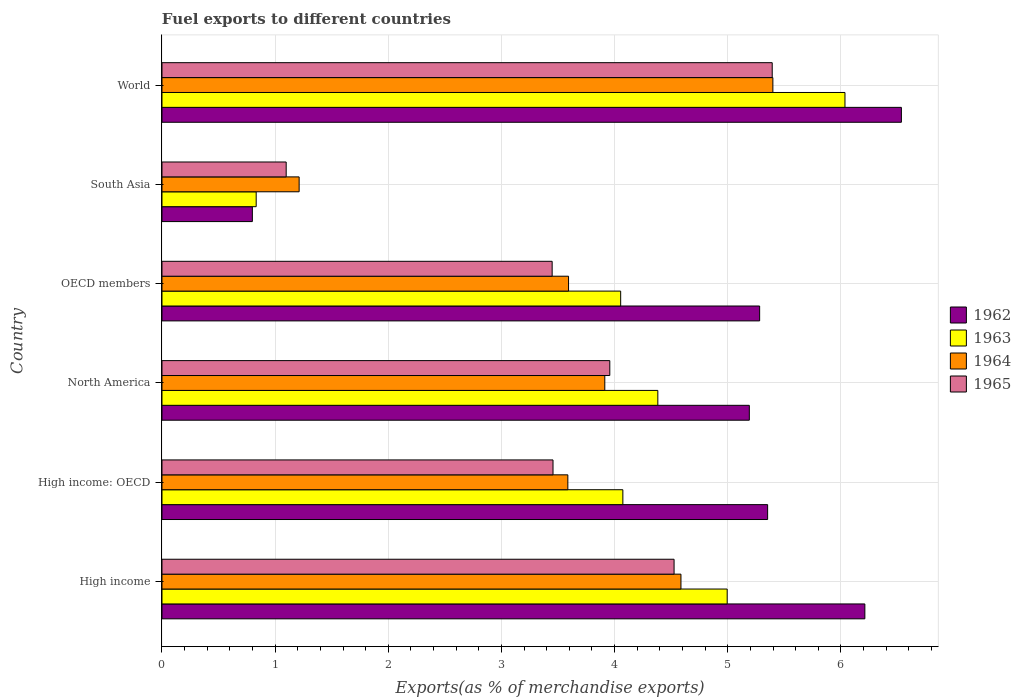How many different coloured bars are there?
Your response must be concise. 4. How many groups of bars are there?
Your answer should be compact. 6. Are the number of bars on each tick of the Y-axis equal?
Make the answer very short. Yes. How many bars are there on the 1st tick from the top?
Provide a short and direct response. 4. How many bars are there on the 1st tick from the bottom?
Provide a succinct answer. 4. In how many cases, is the number of bars for a given country not equal to the number of legend labels?
Your response must be concise. 0. What is the percentage of exports to different countries in 1964 in High income: OECD?
Provide a short and direct response. 3.59. Across all countries, what is the maximum percentage of exports to different countries in 1964?
Keep it short and to the point. 5.4. Across all countries, what is the minimum percentage of exports to different countries in 1963?
Your response must be concise. 0.83. In which country was the percentage of exports to different countries in 1962 maximum?
Provide a short and direct response. World. In which country was the percentage of exports to different countries in 1964 minimum?
Ensure brevity in your answer.  South Asia. What is the total percentage of exports to different countries in 1962 in the graph?
Your answer should be very brief. 29.37. What is the difference between the percentage of exports to different countries in 1962 in North America and that in South Asia?
Make the answer very short. 4.39. What is the difference between the percentage of exports to different countries in 1965 in OECD members and the percentage of exports to different countries in 1964 in High income?
Ensure brevity in your answer.  -1.14. What is the average percentage of exports to different countries in 1964 per country?
Your answer should be very brief. 3.72. What is the difference between the percentage of exports to different countries in 1963 and percentage of exports to different countries in 1962 in High income?
Your answer should be compact. -1.22. What is the ratio of the percentage of exports to different countries in 1964 in OECD members to that in World?
Make the answer very short. 0.67. What is the difference between the highest and the second highest percentage of exports to different countries in 1962?
Your answer should be very brief. 0.32. What is the difference between the highest and the lowest percentage of exports to different countries in 1962?
Give a very brief answer. 5.74. In how many countries, is the percentage of exports to different countries in 1965 greater than the average percentage of exports to different countries in 1965 taken over all countries?
Provide a succinct answer. 3. Is the sum of the percentage of exports to different countries in 1963 in High income and OECD members greater than the maximum percentage of exports to different countries in 1964 across all countries?
Offer a very short reply. Yes. What does the 2nd bar from the top in North America represents?
Your answer should be compact. 1964. What does the 3rd bar from the bottom in South Asia represents?
Provide a succinct answer. 1964. Is it the case that in every country, the sum of the percentage of exports to different countries in 1963 and percentage of exports to different countries in 1962 is greater than the percentage of exports to different countries in 1965?
Offer a terse response. Yes. How many bars are there?
Your response must be concise. 24. How many countries are there in the graph?
Provide a short and direct response. 6. What is the difference between two consecutive major ticks on the X-axis?
Your answer should be very brief. 1. Does the graph contain any zero values?
Offer a terse response. No. Does the graph contain grids?
Ensure brevity in your answer.  Yes. Where does the legend appear in the graph?
Provide a short and direct response. Center right. How are the legend labels stacked?
Provide a short and direct response. Vertical. What is the title of the graph?
Offer a terse response. Fuel exports to different countries. Does "2005" appear as one of the legend labels in the graph?
Ensure brevity in your answer.  No. What is the label or title of the X-axis?
Your response must be concise. Exports(as % of merchandise exports). What is the Exports(as % of merchandise exports) in 1962 in High income?
Make the answer very short. 6.21. What is the Exports(as % of merchandise exports) in 1963 in High income?
Offer a very short reply. 5. What is the Exports(as % of merchandise exports) in 1964 in High income?
Your response must be concise. 4.59. What is the Exports(as % of merchandise exports) of 1965 in High income?
Your response must be concise. 4.53. What is the Exports(as % of merchandise exports) of 1962 in High income: OECD?
Provide a short and direct response. 5.35. What is the Exports(as % of merchandise exports) of 1963 in High income: OECD?
Your answer should be compact. 4.07. What is the Exports(as % of merchandise exports) of 1964 in High income: OECD?
Your answer should be compact. 3.59. What is the Exports(as % of merchandise exports) in 1965 in High income: OECD?
Ensure brevity in your answer.  3.46. What is the Exports(as % of merchandise exports) of 1962 in North America?
Provide a short and direct response. 5.19. What is the Exports(as % of merchandise exports) in 1963 in North America?
Provide a succinct answer. 4.38. What is the Exports(as % of merchandise exports) in 1964 in North America?
Make the answer very short. 3.91. What is the Exports(as % of merchandise exports) of 1965 in North America?
Provide a short and direct response. 3.96. What is the Exports(as % of merchandise exports) of 1962 in OECD members?
Ensure brevity in your answer.  5.28. What is the Exports(as % of merchandise exports) of 1963 in OECD members?
Provide a succinct answer. 4.05. What is the Exports(as % of merchandise exports) of 1964 in OECD members?
Your answer should be very brief. 3.59. What is the Exports(as % of merchandise exports) in 1965 in OECD members?
Your answer should be compact. 3.45. What is the Exports(as % of merchandise exports) of 1962 in South Asia?
Your response must be concise. 0.8. What is the Exports(as % of merchandise exports) of 1963 in South Asia?
Offer a terse response. 0.83. What is the Exports(as % of merchandise exports) in 1964 in South Asia?
Your answer should be very brief. 1.21. What is the Exports(as % of merchandise exports) in 1965 in South Asia?
Offer a terse response. 1.1. What is the Exports(as % of merchandise exports) in 1962 in World?
Offer a terse response. 6.53. What is the Exports(as % of merchandise exports) of 1963 in World?
Ensure brevity in your answer.  6.04. What is the Exports(as % of merchandise exports) of 1964 in World?
Keep it short and to the point. 5.4. What is the Exports(as % of merchandise exports) of 1965 in World?
Provide a short and direct response. 5.39. Across all countries, what is the maximum Exports(as % of merchandise exports) in 1962?
Your response must be concise. 6.53. Across all countries, what is the maximum Exports(as % of merchandise exports) of 1963?
Make the answer very short. 6.04. Across all countries, what is the maximum Exports(as % of merchandise exports) in 1964?
Ensure brevity in your answer.  5.4. Across all countries, what is the maximum Exports(as % of merchandise exports) of 1965?
Your response must be concise. 5.39. Across all countries, what is the minimum Exports(as % of merchandise exports) of 1962?
Offer a terse response. 0.8. Across all countries, what is the minimum Exports(as % of merchandise exports) in 1963?
Your answer should be compact. 0.83. Across all countries, what is the minimum Exports(as % of merchandise exports) of 1964?
Provide a short and direct response. 1.21. Across all countries, what is the minimum Exports(as % of merchandise exports) of 1965?
Provide a succinct answer. 1.1. What is the total Exports(as % of merchandise exports) of 1962 in the graph?
Provide a succinct answer. 29.37. What is the total Exports(as % of merchandise exports) of 1963 in the graph?
Your response must be concise. 24.37. What is the total Exports(as % of merchandise exports) of 1964 in the graph?
Offer a terse response. 22.29. What is the total Exports(as % of merchandise exports) in 1965 in the graph?
Provide a succinct answer. 21.88. What is the difference between the Exports(as % of merchandise exports) of 1962 in High income and that in High income: OECD?
Ensure brevity in your answer.  0.86. What is the difference between the Exports(as % of merchandise exports) in 1963 in High income and that in High income: OECD?
Provide a short and direct response. 0.92. What is the difference between the Exports(as % of merchandise exports) in 1964 in High income and that in High income: OECD?
Your response must be concise. 1. What is the difference between the Exports(as % of merchandise exports) in 1965 in High income and that in High income: OECD?
Provide a succinct answer. 1.07. What is the difference between the Exports(as % of merchandise exports) of 1963 in High income and that in North America?
Your answer should be very brief. 0.61. What is the difference between the Exports(as % of merchandise exports) of 1964 in High income and that in North America?
Provide a short and direct response. 0.67. What is the difference between the Exports(as % of merchandise exports) of 1965 in High income and that in North America?
Keep it short and to the point. 0.57. What is the difference between the Exports(as % of merchandise exports) in 1962 in High income and that in OECD members?
Your answer should be very brief. 0.93. What is the difference between the Exports(as % of merchandise exports) of 1963 in High income and that in OECD members?
Make the answer very short. 0.94. What is the difference between the Exports(as % of merchandise exports) of 1964 in High income and that in OECD members?
Your response must be concise. 0.99. What is the difference between the Exports(as % of merchandise exports) in 1965 in High income and that in OECD members?
Offer a very short reply. 1.08. What is the difference between the Exports(as % of merchandise exports) of 1962 in High income and that in South Asia?
Offer a terse response. 5.41. What is the difference between the Exports(as % of merchandise exports) in 1963 in High income and that in South Asia?
Your response must be concise. 4.16. What is the difference between the Exports(as % of merchandise exports) in 1964 in High income and that in South Asia?
Keep it short and to the point. 3.37. What is the difference between the Exports(as % of merchandise exports) of 1965 in High income and that in South Asia?
Keep it short and to the point. 3.43. What is the difference between the Exports(as % of merchandise exports) of 1962 in High income and that in World?
Your response must be concise. -0.32. What is the difference between the Exports(as % of merchandise exports) of 1963 in High income and that in World?
Make the answer very short. -1.04. What is the difference between the Exports(as % of merchandise exports) of 1964 in High income and that in World?
Offer a very short reply. -0.81. What is the difference between the Exports(as % of merchandise exports) of 1965 in High income and that in World?
Ensure brevity in your answer.  -0.87. What is the difference between the Exports(as % of merchandise exports) of 1962 in High income: OECD and that in North America?
Give a very brief answer. 0.16. What is the difference between the Exports(as % of merchandise exports) of 1963 in High income: OECD and that in North America?
Offer a terse response. -0.31. What is the difference between the Exports(as % of merchandise exports) of 1964 in High income: OECD and that in North America?
Your answer should be very brief. -0.33. What is the difference between the Exports(as % of merchandise exports) of 1965 in High income: OECD and that in North America?
Your response must be concise. -0.5. What is the difference between the Exports(as % of merchandise exports) of 1962 in High income: OECD and that in OECD members?
Offer a terse response. 0.07. What is the difference between the Exports(as % of merchandise exports) in 1963 in High income: OECD and that in OECD members?
Ensure brevity in your answer.  0.02. What is the difference between the Exports(as % of merchandise exports) in 1964 in High income: OECD and that in OECD members?
Provide a succinct answer. -0.01. What is the difference between the Exports(as % of merchandise exports) of 1965 in High income: OECD and that in OECD members?
Offer a very short reply. 0.01. What is the difference between the Exports(as % of merchandise exports) in 1962 in High income: OECD and that in South Asia?
Make the answer very short. 4.55. What is the difference between the Exports(as % of merchandise exports) in 1963 in High income: OECD and that in South Asia?
Ensure brevity in your answer.  3.24. What is the difference between the Exports(as % of merchandise exports) of 1964 in High income: OECD and that in South Asia?
Your answer should be compact. 2.37. What is the difference between the Exports(as % of merchandise exports) in 1965 in High income: OECD and that in South Asia?
Offer a terse response. 2.36. What is the difference between the Exports(as % of merchandise exports) in 1962 in High income: OECD and that in World?
Your answer should be compact. -1.18. What is the difference between the Exports(as % of merchandise exports) of 1963 in High income: OECD and that in World?
Make the answer very short. -1.96. What is the difference between the Exports(as % of merchandise exports) in 1964 in High income: OECD and that in World?
Provide a succinct answer. -1.81. What is the difference between the Exports(as % of merchandise exports) in 1965 in High income: OECD and that in World?
Provide a short and direct response. -1.94. What is the difference between the Exports(as % of merchandise exports) of 1962 in North America and that in OECD members?
Your response must be concise. -0.09. What is the difference between the Exports(as % of merchandise exports) of 1963 in North America and that in OECD members?
Offer a terse response. 0.33. What is the difference between the Exports(as % of merchandise exports) in 1964 in North America and that in OECD members?
Give a very brief answer. 0.32. What is the difference between the Exports(as % of merchandise exports) in 1965 in North America and that in OECD members?
Your answer should be compact. 0.51. What is the difference between the Exports(as % of merchandise exports) in 1962 in North America and that in South Asia?
Your answer should be compact. 4.39. What is the difference between the Exports(as % of merchandise exports) of 1963 in North America and that in South Asia?
Offer a very short reply. 3.55. What is the difference between the Exports(as % of merchandise exports) of 1964 in North America and that in South Asia?
Your answer should be compact. 2.7. What is the difference between the Exports(as % of merchandise exports) of 1965 in North America and that in South Asia?
Give a very brief answer. 2.86. What is the difference between the Exports(as % of merchandise exports) in 1962 in North America and that in World?
Make the answer very short. -1.34. What is the difference between the Exports(as % of merchandise exports) of 1963 in North America and that in World?
Your answer should be compact. -1.65. What is the difference between the Exports(as % of merchandise exports) in 1964 in North America and that in World?
Provide a short and direct response. -1.49. What is the difference between the Exports(as % of merchandise exports) in 1965 in North America and that in World?
Provide a short and direct response. -1.44. What is the difference between the Exports(as % of merchandise exports) in 1962 in OECD members and that in South Asia?
Offer a terse response. 4.48. What is the difference between the Exports(as % of merchandise exports) of 1963 in OECD members and that in South Asia?
Provide a succinct answer. 3.22. What is the difference between the Exports(as % of merchandise exports) in 1964 in OECD members and that in South Asia?
Your response must be concise. 2.38. What is the difference between the Exports(as % of merchandise exports) of 1965 in OECD members and that in South Asia?
Provide a succinct answer. 2.35. What is the difference between the Exports(as % of merchandise exports) in 1962 in OECD members and that in World?
Your response must be concise. -1.25. What is the difference between the Exports(as % of merchandise exports) in 1963 in OECD members and that in World?
Provide a succinct answer. -1.98. What is the difference between the Exports(as % of merchandise exports) of 1964 in OECD members and that in World?
Your answer should be very brief. -1.81. What is the difference between the Exports(as % of merchandise exports) in 1965 in OECD members and that in World?
Offer a terse response. -1.94. What is the difference between the Exports(as % of merchandise exports) of 1962 in South Asia and that in World?
Provide a short and direct response. -5.74. What is the difference between the Exports(as % of merchandise exports) in 1963 in South Asia and that in World?
Offer a very short reply. -5.2. What is the difference between the Exports(as % of merchandise exports) of 1964 in South Asia and that in World?
Your answer should be compact. -4.19. What is the difference between the Exports(as % of merchandise exports) of 1965 in South Asia and that in World?
Ensure brevity in your answer.  -4.3. What is the difference between the Exports(as % of merchandise exports) in 1962 in High income and the Exports(as % of merchandise exports) in 1963 in High income: OECD?
Your answer should be very brief. 2.14. What is the difference between the Exports(as % of merchandise exports) of 1962 in High income and the Exports(as % of merchandise exports) of 1964 in High income: OECD?
Your response must be concise. 2.62. What is the difference between the Exports(as % of merchandise exports) of 1962 in High income and the Exports(as % of merchandise exports) of 1965 in High income: OECD?
Ensure brevity in your answer.  2.76. What is the difference between the Exports(as % of merchandise exports) of 1963 in High income and the Exports(as % of merchandise exports) of 1964 in High income: OECD?
Offer a terse response. 1.41. What is the difference between the Exports(as % of merchandise exports) of 1963 in High income and the Exports(as % of merchandise exports) of 1965 in High income: OECD?
Ensure brevity in your answer.  1.54. What is the difference between the Exports(as % of merchandise exports) of 1964 in High income and the Exports(as % of merchandise exports) of 1965 in High income: OECD?
Ensure brevity in your answer.  1.13. What is the difference between the Exports(as % of merchandise exports) in 1962 in High income and the Exports(as % of merchandise exports) in 1963 in North America?
Ensure brevity in your answer.  1.83. What is the difference between the Exports(as % of merchandise exports) of 1962 in High income and the Exports(as % of merchandise exports) of 1964 in North America?
Your answer should be very brief. 2.3. What is the difference between the Exports(as % of merchandise exports) in 1962 in High income and the Exports(as % of merchandise exports) in 1965 in North America?
Offer a very short reply. 2.25. What is the difference between the Exports(as % of merchandise exports) of 1963 in High income and the Exports(as % of merchandise exports) of 1964 in North America?
Your answer should be compact. 1.08. What is the difference between the Exports(as % of merchandise exports) of 1963 in High income and the Exports(as % of merchandise exports) of 1965 in North America?
Ensure brevity in your answer.  1.04. What is the difference between the Exports(as % of merchandise exports) of 1964 in High income and the Exports(as % of merchandise exports) of 1965 in North America?
Provide a short and direct response. 0.63. What is the difference between the Exports(as % of merchandise exports) of 1962 in High income and the Exports(as % of merchandise exports) of 1963 in OECD members?
Make the answer very short. 2.16. What is the difference between the Exports(as % of merchandise exports) in 1962 in High income and the Exports(as % of merchandise exports) in 1964 in OECD members?
Ensure brevity in your answer.  2.62. What is the difference between the Exports(as % of merchandise exports) of 1962 in High income and the Exports(as % of merchandise exports) of 1965 in OECD members?
Give a very brief answer. 2.76. What is the difference between the Exports(as % of merchandise exports) of 1963 in High income and the Exports(as % of merchandise exports) of 1964 in OECD members?
Ensure brevity in your answer.  1.4. What is the difference between the Exports(as % of merchandise exports) of 1963 in High income and the Exports(as % of merchandise exports) of 1965 in OECD members?
Offer a terse response. 1.55. What is the difference between the Exports(as % of merchandise exports) of 1964 in High income and the Exports(as % of merchandise exports) of 1965 in OECD members?
Your answer should be very brief. 1.14. What is the difference between the Exports(as % of merchandise exports) in 1962 in High income and the Exports(as % of merchandise exports) in 1963 in South Asia?
Offer a very short reply. 5.38. What is the difference between the Exports(as % of merchandise exports) in 1962 in High income and the Exports(as % of merchandise exports) in 1964 in South Asia?
Your answer should be very brief. 5. What is the difference between the Exports(as % of merchandise exports) in 1962 in High income and the Exports(as % of merchandise exports) in 1965 in South Asia?
Offer a very short reply. 5.11. What is the difference between the Exports(as % of merchandise exports) in 1963 in High income and the Exports(as % of merchandise exports) in 1964 in South Asia?
Give a very brief answer. 3.78. What is the difference between the Exports(as % of merchandise exports) in 1963 in High income and the Exports(as % of merchandise exports) in 1965 in South Asia?
Offer a very short reply. 3.9. What is the difference between the Exports(as % of merchandise exports) of 1964 in High income and the Exports(as % of merchandise exports) of 1965 in South Asia?
Ensure brevity in your answer.  3.49. What is the difference between the Exports(as % of merchandise exports) of 1962 in High income and the Exports(as % of merchandise exports) of 1963 in World?
Your answer should be very brief. 0.18. What is the difference between the Exports(as % of merchandise exports) in 1962 in High income and the Exports(as % of merchandise exports) in 1964 in World?
Your answer should be compact. 0.81. What is the difference between the Exports(as % of merchandise exports) in 1962 in High income and the Exports(as % of merchandise exports) in 1965 in World?
Provide a short and direct response. 0.82. What is the difference between the Exports(as % of merchandise exports) in 1963 in High income and the Exports(as % of merchandise exports) in 1964 in World?
Your answer should be very brief. -0.4. What is the difference between the Exports(as % of merchandise exports) in 1963 in High income and the Exports(as % of merchandise exports) in 1965 in World?
Ensure brevity in your answer.  -0.4. What is the difference between the Exports(as % of merchandise exports) of 1964 in High income and the Exports(as % of merchandise exports) of 1965 in World?
Ensure brevity in your answer.  -0.81. What is the difference between the Exports(as % of merchandise exports) of 1962 in High income: OECD and the Exports(as % of merchandise exports) of 1963 in North America?
Make the answer very short. 0.97. What is the difference between the Exports(as % of merchandise exports) in 1962 in High income: OECD and the Exports(as % of merchandise exports) in 1964 in North America?
Offer a very short reply. 1.44. What is the difference between the Exports(as % of merchandise exports) of 1962 in High income: OECD and the Exports(as % of merchandise exports) of 1965 in North America?
Offer a very short reply. 1.39. What is the difference between the Exports(as % of merchandise exports) of 1963 in High income: OECD and the Exports(as % of merchandise exports) of 1964 in North America?
Ensure brevity in your answer.  0.16. What is the difference between the Exports(as % of merchandise exports) of 1963 in High income: OECD and the Exports(as % of merchandise exports) of 1965 in North America?
Your response must be concise. 0.12. What is the difference between the Exports(as % of merchandise exports) of 1964 in High income: OECD and the Exports(as % of merchandise exports) of 1965 in North America?
Provide a succinct answer. -0.37. What is the difference between the Exports(as % of merchandise exports) of 1962 in High income: OECD and the Exports(as % of merchandise exports) of 1963 in OECD members?
Give a very brief answer. 1.3. What is the difference between the Exports(as % of merchandise exports) of 1962 in High income: OECD and the Exports(as % of merchandise exports) of 1964 in OECD members?
Offer a terse response. 1.76. What is the difference between the Exports(as % of merchandise exports) of 1962 in High income: OECD and the Exports(as % of merchandise exports) of 1965 in OECD members?
Offer a terse response. 1.9. What is the difference between the Exports(as % of merchandise exports) of 1963 in High income: OECD and the Exports(as % of merchandise exports) of 1964 in OECD members?
Make the answer very short. 0.48. What is the difference between the Exports(as % of merchandise exports) in 1963 in High income: OECD and the Exports(as % of merchandise exports) in 1965 in OECD members?
Give a very brief answer. 0.62. What is the difference between the Exports(as % of merchandise exports) of 1964 in High income: OECD and the Exports(as % of merchandise exports) of 1965 in OECD members?
Your answer should be compact. 0.14. What is the difference between the Exports(as % of merchandise exports) of 1962 in High income: OECD and the Exports(as % of merchandise exports) of 1963 in South Asia?
Your response must be concise. 4.52. What is the difference between the Exports(as % of merchandise exports) in 1962 in High income: OECD and the Exports(as % of merchandise exports) in 1964 in South Asia?
Keep it short and to the point. 4.14. What is the difference between the Exports(as % of merchandise exports) in 1962 in High income: OECD and the Exports(as % of merchandise exports) in 1965 in South Asia?
Keep it short and to the point. 4.25. What is the difference between the Exports(as % of merchandise exports) in 1963 in High income: OECD and the Exports(as % of merchandise exports) in 1964 in South Asia?
Offer a terse response. 2.86. What is the difference between the Exports(as % of merchandise exports) in 1963 in High income: OECD and the Exports(as % of merchandise exports) in 1965 in South Asia?
Provide a succinct answer. 2.98. What is the difference between the Exports(as % of merchandise exports) of 1964 in High income: OECD and the Exports(as % of merchandise exports) of 1965 in South Asia?
Ensure brevity in your answer.  2.49. What is the difference between the Exports(as % of merchandise exports) of 1962 in High income: OECD and the Exports(as % of merchandise exports) of 1963 in World?
Keep it short and to the point. -0.68. What is the difference between the Exports(as % of merchandise exports) in 1962 in High income: OECD and the Exports(as % of merchandise exports) in 1964 in World?
Provide a succinct answer. -0.05. What is the difference between the Exports(as % of merchandise exports) in 1962 in High income: OECD and the Exports(as % of merchandise exports) in 1965 in World?
Give a very brief answer. -0.04. What is the difference between the Exports(as % of merchandise exports) in 1963 in High income: OECD and the Exports(as % of merchandise exports) in 1964 in World?
Provide a succinct answer. -1.33. What is the difference between the Exports(as % of merchandise exports) of 1963 in High income: OECD and the Exports(as % of merchandise exports) of 1965 in World?
Your answer should be compact. -1.32. What is the difference between the Exports(as % of merchandise exports) in 1964 in High income: OECD and the Exports(as % of merchandise exports) in 1965 in World?
Ensure brevity in your answer.  -1.81. What is the difference between the Exports(as % of merchandise exports) of 1962 in North America and the Exports(as % of merchandise exports) of 1963 in OECD members?
Provide a succinct answer. 1.14. What is the difference between the Exports(as % of merchandise exports) of 1962 in North America and the Exports(as % of merchandise exports) of 1964 in OECD members?
Your answer should be compact. 1.6. What is the difference between the Exports(as % of merchandise exports) of 1962 in North America and the Exports(as % of merchandise exports) of 1965 in OECD members?
Keep it short and to the point. 1.74. What is the difference between the Exports(as % of merchandise exports) in 1963 in North America and the Exports(as % of merchandise exports) in 1964 in OECD members?
Make the answer very short. 0.79. What is the difference between the Exports(as % of merchandise exports) of 1963 in North America and the Exports(as % of merchandise exports) of 1965 in OECD members?
Make the answer very short. 0.93. What is the difference between the Exports(as % of merchandise exports) of 1964 in North America and the Exports(as % of merchandise exports) of 1965 in OECD members?
Ensure brevity in your answer.  0.47. What is the difference between the Exports(as % of merchandise exports) in 1962 in North America and the Exports(as % of merchandise exports) in 1963 in South Asia?
Your answer should be very brief. 4.36. What is the difference between the Exports(as % of merchandise exports) in 1962 in North America and the Exports(as % of merchandise exports) in 1964 in South Asia?
Give a very brief answer. 3.98. What is the difference between the Exports(as % of merchandise exports) of 1962 in North America and the Exports(as % of merchandise exports) of 1965 in South Asia?
Your answer should be compact. 4.09. What is the difference between the Exports(as % of merchandise exports) in 1963 in North America and the Exports(as % of merchandise exports) in 1964 in South Asia?
Offer a very short reply. 3.17. What is the difference between the Exports(as % of merchandise exports) of 1963 in North America and the Exports(as % of merchandise exports) of 1965 in South Asia?
Provide a short and direct response. 3.28. What is the difference between the Exports(as % of merchandise exports) of 1964 in North America and the Exports(as % of merchandise exports) of 1965 in South Asia?
Offer a very short reply. 2.82. What is the difference between the Exports(as % of merchandise exports) in 1962 in North America and the Exports(as % of merchandise exports) in 1963 in World?
Give a very brief answer. -0.85. What is the difference between the Exports(as % of merchandise exports) of 1962 in North America and the Exports(as % of merchandise exports) of 1964 in World?
Give a very brief answer. -0.21. What is the difference between the Exports(as % of merchandise exports) of 1962 in North America and the Exports(as % of merchandise exports) of 1965 in World?
Your answer should be very brief. -0.2. What is the difference between the Exports(as % of merchandise exports) in 1963 in North America and the Exports(as % of merchandise exports) in 1964 in World?
Your answer should be compact. -1.02. What is the difference between the Exports(as % of merchandise exports) in 1963 in North America and the Exports(as % of merchandise exports) in 1965 in World?
Provide a short and direct response. -1.01. What is the difference between the Exports(as % of merchandise exports) in 1964 in North America and the Exports(as % of merchandise exports) in 1965 in World?
Offer a terse response. -1.48. What is the difference between the Exports(as % of merchandise exports) of 1962 in OECD members and the Exports(as % of merchandise exports) of 1963 in South Asia?
Make the answer very short. 4.45. What is the difference between the Exports(as % of merchandise exports) in 1962 in OECD members and the Exports(as % of merchandise exports) in 1964 in South Asia?
Ensure brevity in your answer.  4.07. What is the difference between the Exports(as % of merchandise exports) of 1962 in OECD members and the Exports(as % of merchandise exports) of 1965 in South Asia?
Give a very brief answer. 4.18. What is the difference between the Exports(as % of merchandise exports) of 1963 in OECD members and the Exports(as % of merchandise exports) of 1964 in South Asia?
Offer a terse response. 2.84. What is the difference between the Exports(as % of merchandise exports) of 1963 in OECD members and the Exports(as % of merchandise exports) of 1965 in South Asia?
Provide a succinct answer. 2.96. What is the difference between the Exports(as % of merchandise exports) in 1964 in OECD members and the Exports(as % of merchandise exports) in 1965 in South Asia?
Offer a terse response. 2.5. What is the difference between the Exports(as % of merchandise exports) of 1962 in OECD members and the Exports(as % of merchandise exports) of 1963 in World?
Offer a very short reply. -0.75. What is the difference between the Exports(as % of merchandise exports) in 1962 in OECD members and the Exports(as % of merchandise exports) in 1964 in World?
Offer a very short reply. -0.12. What is the difference between the Exports(as % of merchandise exports) of 1962 in OECD members and the Exports(as % of merchandise exports) of 1965 in World?
Keep it short and to the point. -0.11. What is the difference between the Exports(as % of merchandise exports) of 1963 in OECD members and the Exports(as % of merchandise exports) of 1964 in World?
Offer a terse response. -1.35. What is the difference between the Exports(as % of merchandise exports) of 1963 in OECD members and the Exports(as % of merchandise exports) of 1965 in World?
Ensure brevity in your answer.  -1.34. What is the difference between the Exports(as % of merchandise exports) of 1964 in OECD members and the Exports(as % of merchandise exports) of 1965 in World?
Ensure brevity in your answer.  -1.8. What is the difference between the Exports(as % of merchandise exports) of 1962 in South Asia and the Exports(as % of merchandise exports) of 1963 in World?
Your answer should be compact. -5.24. What is the difference between the Exports(as % of merchandise exports) in 1962 in South Asia and the Exports(as % of merchandise exports) in 1964 in World?
Your answer should be compact. -4.6. What is the difference between the Exports(as % of merchandise exports) of 1962 in South Asia and the Exports(as % of merchandise exports) of 1965 in World?
Keep it short and to the point. -4.59. What is the difference between the Exports(as % of merchandise exports) in 1963 in South Asia and the Exports(as % of merchandise exports) in 1964 in World?
Give a very brief answer. -4.57. What is the difference between the Exports(as % of merchandise exports) in 1963 in South Asia and the Exports(as % of merchandise exports) in 1965 in World?
Your answer should be compact. -4.56. What is the difference between the Exports(as % of merchandise exports) of 1964 in South Asia and the Exports(as % of merchandise exports) of 1965 in World?
Your answer should be compact. -4.18. What is the average Exports(as % of merchandise exports) of 1962 per country?
Provide a short and direct response. 4.9. What is the average Exports(as % of merchandise exports) of 1963 per country?
Provide a succinct answer. 4.06. What is the average Exports(as % of merchandise exports) in 1964 per country?
Keep it short and to the point. 3.72. What is the average Exports(as % of merchandise exports) in 1965 per country?
Give a very brief answer. 3.65. What is the difference between the Exports(as % of merchandise exports) in 1962 and Exports(as % of merchandise exports) in 1963 in High income?
Your answer should be compact. 1.22. What is the difference between the Exports(as % of merchandise exports) in 1962 and Exports(as % of merchandise exports) in 1964 in High income?
Your answer should be compact. 1.63. What is the difference between the Exports(as % of merchandise exports) in 1962 and Exports(as % of merchandise exports) in 1965 in High income?
Keep it short and to the point. 1.69. What is the difference between the Exports(as % of merchandise exports) of 1963 and Exports(as % of merchandise exports) of 1964 in High income?
Your answer should be compact. 0.41. What is the difference between the Exports(as % of merchandise exports) of 1963 and Exports(as % of merchandise exports) of 1965 in High income?
Offer a very short reply. 0.47. What is the difference between the Exports(as % of merchandise exports) of 1964 and Exports(as % of merchandise exports) of 1965 in High income?
Ensure brevity in your answer.  0.06. What is the difference between the Exports(as % of merchandise exports) of 1962 and Exports(as % of merchandise exports) of 1963 in High income: OECD?
Your response must be concise. 1.28. What is the difference between the Exports(as % of merchandise exports) of 1962 and Exports(as % of merchandise exports) of 1964 in High income: OECD?
Offer a very short reply. 1.77. What is the difference between the Exports(as % of merchandise exports) in 1962 and Exports(as % of merchandise exports) in 1965 in High income: OECD?
Keep it short and to the point. 1.9. What is the difference between the Exports(as % of merchandise exports) in 1963 and Exports(as % of merchandise exports) in 1964 in High income: OECD?
Offer a terse response. 0.49. What is the difference between the Exports(as % of merchandise exports) in 1963 and Exports(as % of merchandise exports) in 1965 in High income: OECD?
Keep it short and to the point. 0.62. What is the difference between the Exports(as % of merchandise exports) in 1964 and Exports(as % of merchandise exports) in 1965 in High income: OECD?
Make the answer very short. 0.13. What is the difference between the Exports(as % of merchandise exports) of 1962 and Exports(as % of merchandise exports) of 1963 in North America?
Ensure brevity in your answer.  0.81. What is the difference between the Exports(as % of merchandise exports) in 1962 and Exports(as % of merchandise exports) in 1964 in North America?
Provide a short and direct response. 1.28. What is the difference between the Exports(as % of merchandise exports) of 1962 and Exports(as % of merchandise exports) of 1965 in North America?
Offer a very short reply. 1.23. What is the difference between the Exports(as % of merchandise exports) of 1963 and Exports(as % of merchandise exports) of 1964 in North America?
Your answer should be very brief. 0.47. What is the difference between the Exports(as % of merchandise exports) in 1963 and Exports(as % of merchandise exports) in 1965 in North America?
Your response must be concise. 0.42. What is the difference between the Exports(as % of merchandise exports) of 1964 and Exports(as % of merchandise exports) of 1965 in North America?
Keep it short and to the point. -0.04. What is the difference between the Exports(as % of merchandise exports) in 1962 and Exports(as % of merchandise exports) in 1963 in OECD members?
Ensure brevity in your answer.  1.23. What is the difference between the Exports(as % of merchandise exports) in 1962 and Exports(as % of merchandise exports) in 1964 in OECD members?
Your answer should be very brief. 1.69. What is the difference between the Exports(as % of merchandise exports) of 1962 and Exports(as % of merchandise exports) of 1965 in OECD members?
Ensure brevity in your answer.  1.83. What is the difference between the Exports(as % of merchandise exports) of 1963 and Exports(as % of merchandise exports) of 1964 in OECD members?
Make the answer very short. 0.46. What is the difference between the Exports(as % of merchandise exports) of 1963 and Exports(as % of merchandise exports) of 1965 in OECD members?
Your response must be concise. 0.61. What is the difference between the Exports(as % of merchandise exports) of 1964 and Exports(as % of merchandise exports) of 1965 in OECD members?
Offer a very short reply. 0.14. What is the difference between the Exports(as % of merchandise exports) of 1962 and Exports(as % of merchandise exports) of 1963 in South Asia?
Give a very brief answer. -0.03. What is the difference between the Exports(as % of merchandise exports) of 1962 and Exports(as % of merchandise exports) of 1964 in South Asia?
Keep it short and to the point. -0.41. What is the difference between the Exports(as % of merchandise exports) in 1962 and Exports(as % of merchandise exports) in 1965 in South Asia?
Your response must be concise. -0.3. What is the difference between the Exports(as % of merchandise exports) in 1963 and Exports(as % of merchandise exports) in 1964 in South Asia?
Keep it short and to the point. -0.38. What is the difference between the Exports(as % of merchandise exports) of 1963 and Exports(as % of merchandise exports) of 1965 in South Asia?
Your answer should be very brief. -0.27. What is the difference between the Exports(as % of merchandise exports) in 1964 and Exports(as % of merchandise exports) in 1965 in South Asia?
Your answer should be compact. 0.11. What is the difference between the Exports(as % of merchandise exports) in 1962 and Exports(as % of merchandise exports) in 1963 in World?
Offer a very short reply. 0.5. What is the difference between the Exports(as % of merchandise exports) in 1962 and Exports(as % of merchandise exports) in 1964 in World?
Your answer should be compact. 1.14. What is the difference between the Exports(as % of merchandise exports) in 1962 and Exports(as % of merchandise exports) in 1965 in World?
Make the answer very short. 1.14. What is the difference between the Exports(as % of merchandise exports) of 1963 and Exports(as % of merchandise exports) of 1964 in World?
Your answer should be very brief. 0.64. What is the difference between the Exports(as % of merchandise exports) of 1963 and Exports(as % of merchandise exports) of 1965 in World?
Give a very brief answer. 0.64. What is the difference between the Exports(as % of merchandise exports) of 1964 and Exports(as % of merchandise exports) of 1965 in World?
Ensure brevity in your answer.  0.01. What is the ratio of the Exports(as % of merchandise exports) of 1962 in High income to that in High income: OECD?
Offer a terse response. 1.16. What is the ratio of the Exports(as % of merchandise exports) in 1963 in High income to that in High income: OECD?
Provide a succinct answer. 1.23. What is the ratio of the Exports(as % of merchandise exports) in 1964 in High income to that in High income: OECD?
Your answer should be compact. 1.28. What is the ratio of the Exports(as % of merchandise exports) of 1965 in High income to that in High income: OECD?
Your answer should be compact. 1.31. What is the ratio of the Exports(as % of merchandise exports) in 1962 in High income to that in North America?
Your answer should be compact. 1.2. What is the ratio of the Exports(as % of merchandise exports) of 1963 in High income to that in North America?
Keep it short and to the point. 1.14. What is the ratio of the Exports(as % of merchandise exports) of 1964 in High income to that in North America?
Your answer should be very brief. 1.17. What is the ratio of the Exports(as % of merchandise exports) of 1965 in High income to that in North America?
Make the answer very short. 1.14. What is the ratio of the Exports(as % of merchandise exports) of 1962 in High income to that in OECD members?
Your answer should be very brief. 1.18. What is the ratio of the Exports(as % of merchandise exports) in 1963 in High income to that in OECD members?
Keep it short and to the point. 1.23. What is the ratio of the Exports(as % of merchandise exports) in 1964 in High income to that in OECD members?
Provide a succinct answer. 1.28. What is the ratio of the Exports(as % of merchandise exports) in 1965 in High income to that in OECD members?
Provide a succinct answer. 1.31. What is the ratio of the Exports(as % of merchandise exports) of 1962 in High income to that in South Asia?
Give a very brief answer. 7.78. What is the ratio of the Exports(as % of merchandise exports) in 1963 in High income to that in South Asia?
Offer a very short reply. 6. What is the ratio of the Exports(as % of merchandise exports) in 1964 in High income to that in South Asia?
Your answer should be compact. 3.78. What is the ratio of the Exports(as % of merchandise exports) of 1965 in High income to that in South Asia?
Provide a short and direct response. 4.12. What is the ratio of the Exports(as % of merchandise exports) in 1962 in High income to that in World?
Keep it short and to the point. 0.95. What is the ratio of the Exports(as % of merchandise exports) in 1963 in High income to that in World?
Give a very brief answer. 0.83. What is the ratio of the Exports(as % of merchandise exports) of 1964 in High income to that in World?
Your response must be concise. 0.85. What is the ratio of the Exports(as % of merchandise exports) in 1965 in High income to that in World?
Make the answer very short. 0.84. What is the ratio of the Exports(as % of merchandise exports) of 1962 in High income: OECD to that in North America?
Keep it short and to the point. 1.03. What is the ratio of the Exports(as % of merchandise exports) of 1963 in High income: OECD to that in North America?
Your answer should be very brief. 0.93. What is the ratio of the Exports(as % of merchandise exports) of 1964 in High income: OECD to that in North America?
Offer a very short reply. 0.92. What is the ratio of the Exports(as % of merchandise exports) of 1965 in High income: OECD to that in North America?
Provide a short and direct response. 0.87. What is the ratio of the Exports(as % of merchandise exports) in 1962 in High income: OECD to that in OECD members?
Offer a terse response. 1.01. What is the ratio of the Exports(as % of merchandise exports) in 1962 in High income: OECD to that in South Asia?
Provide a succinct answer. 6.7. What is the ratio of the Exports(as % of merchandise exports) in 1963 in High income: OECD to that in South Asia?
Offer a very short reply. 4.89. What is the ratio of the Exports(as % of merchandise exports) of 1964 in High income: OECD to that in South Asia?
Provide a succinct answer. 2.96. What is the ratio of the Exports(as % of merchandise exports) in 1965 in High income: OECD to that in South Asia?
Make the answer very short. 3.15. What is the ratio of the Exports(as % of merchandise exports) in 1962 in High income: OECD to that in World?
Provide a succinct answer. 0.82. What is the ratio of the Exports(as % of merchandise exports) in 1963 in High income: OECD to that in World?
Offer a very short reply. 0.67. What is the ratio of the Exports(as % of merchandise exports) of 1964 in High income: OECD to that in World?
Offer a very short reply. 0.66. What is the ratio of the Exports(as % of merchandise exports) of 1965 in High income: OECD to that in World?
Give a very brief answer. 0.64. What is the ratio of the Exports(as % of merchandise exports) in 1962 in North America to that in OECD members?
Keep it short and to the point. 0.98. What is the ratio of the Exports(as % of merchandise exports) of 1963 in North America to that in OECD members?
Offer a very short reply. 1.08. What is the ratio of the Exports(as % of merchandise exports) in 1964 in North America to that in OECD members?
Provide a short and direct response. 1.09. What is the ratio of the Exports(as % of merchandise exports) in 1965 in North America to that in OECD members?
Provide a short and direct response. 1.15. What is the ratio of the Exports(as % of merchandise exports) in 1962 in North America to that in South Asia?
Keep it short and to the point. 6.5. What is the ratio of the Exports(as % of merchandise exports) in 1963 in North America to that in South Asia?
Make the answer very short. 5.26. What is the ratio of the Exports(as % of merchandise exports) in 1964 in North America to that in South Asia?
Provide a succinct answer. 3.23. What is the ratio of the Exports(as % of merchandise exports) in 1965 in North America to that in South Asia?
Your answer should be very brief. 3.61. What is the ratio of the Exports(as % of merchandise exports) in 1962 in North America to that in World?
Provide a short and direct response. 0.79. What is the ratio of the Exports(as % of merchandise exports) of 1963 in North America to that in World?
Your answer should be compact. 0.73. What is the ratio of the Exports(as % of merchandise exports) of 1964 in North America to that in World?
Make the answer very short. 0.72. What is the ratio of the Exports(as % of merchandise exports) in 1965 in North America to that in World?
Give a very brief answer. 0.73. What is the ratio of the Exports(as % of merchandise exports) in 1962 in OECD members to that in South Asia?
Your response must be concise. 6.61. What is the ratio of the Exports(as % of merchandise exports) of 1963 in OECD members to that in South Asia?
Your answer should be very brief. 4.87. What is the ratio of the Exports(as % of merchandise exports) in 1964 in OECD members to that in South Asia?
Your answer should be compact. 2.96. What is the ratio of the Exports(as % of merchandise exports) of 1965 in OECD members to that in South Asia?
Keep it short and to the point. 3.14. What is the ratio of the Exports(as % of merchandise exports) of 1962 in OECD members to that in World?
Keep it short and to the point. 0.81. What is the ratio of the Exports(as % of merchandise exports) of 1963 in OECD members to that in World?
Keep it short and to the point. 0.67. What is the ratio of the Exports(as % of merchandise exports) in 1964 in OECD members to that in World?
Your answer should be compact. 0.67. What is the ratio of the Exports(as % of merchandise exports) of 1965 in OECD members to that in World?
Offer a terse response. 0.64. What is the ratio of the Exports(as % of merchandise exports) of 1962 in South Asia to that in World?
Provide a short and direct response. 0.12. What is the ratio of the Exports(as % of merchandise exports) in 1963 in South Asia to that in World?
Make the answer very short. 0.14. What is the ratio of the Exports(as % of merchandise exports) of 1964 in South Asia to that in World?
Provide a short and direct response. 0.22. What is the ratio of the Exports(as % of merchandise exports) of 1965 in South Asia to that in World?
Provide a succinct answer. 0.2. What is the difference between the highest and the second highest Exports(as % of merchandise exports) of 1962?
Provide a succinct answer. 0.32. What is the difference between the highest and the second highest Exports(as % of merchandise exports) in 1963?
Your response must be concise. 1.04. What is the difference between the highest and the second highest Exports(as % of merchandise exports) in 1964?
Your answer should be very brief. 0.81. What is the difference between the highest and the second highest Exports(as % of merchandise exports) in 1965?
Your answer should be compact. 0.87. What is the difference between the highest and the lowest Exports(as % of merchandise exports) of 1962?
Offer a very short reply. 5.74. What is the difference between the highest and the lowest Exports(as % of merchandise exports) in 1963?
Offer a terse response. 5.2. What is the difference between the highest and the lowest Exports(as % of merchandise exports) in 1964?
Make the answer very short. 4.19. What is the difference between the highest and the lowest Exports(as % of merchandise exports) of 1965?
Your answer should be compact. 4.3. 